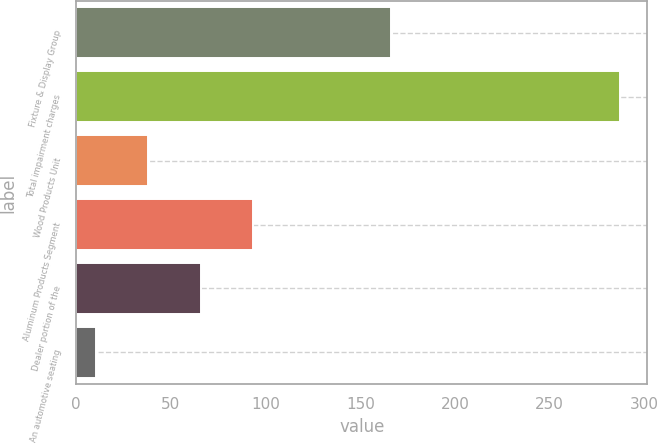Convert chart to OTSL. <chart><loc_0><loc_0><loc_500><loc_500><bar_chart><fcel>Fixture & Display Group<fcel>Total impairment charges<fcel>Wood Products Unit<fcel>Aluminum Products Segment<fcel>Dealer portion of the<fcel>An automotive seating<nl><fcel>166.06<fcel>287.1<fcel>38.16<fcel>93.48<fcel>65.82<fcel>10.5<nl></chart> 